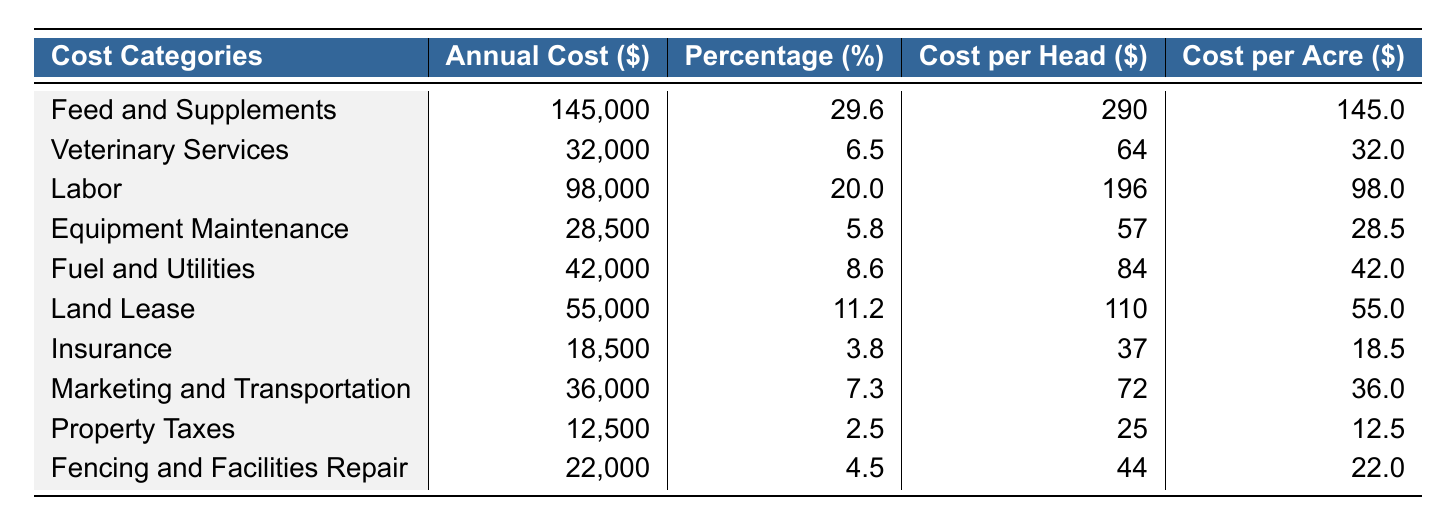What is the annual cost of Feed and Supplements? The table lists the annual costs for each category, and for Feed and Supplements, the value is directly provided as 145,000 dollars.
Answer: 145000 What percentage of total costs does Labor account for? The table shows that Labor accounts for 20.0% of the total costs, as noted in the Percentage column next to Labor.
Answer: 20.0% Which cost category has the highest annual cost? By comparing all annual cost values in the table, Feed and Supplements has the highest value at 145,000 dollars.
Answer: Feed and Supplements What is the total annual cost for Veterinary Services and Insurance combined? The annual cost for Veterinary Services is 32,000 dollars, and for Insurance, it's 18,500 dollars. Adding these gives 32,000 + 18,500 = 50,500 dollars as the total.
Answer: 50500 Is the annual cost for Fencing and Facilities Repair more or less than that for Property Taxes? The annual cost for Fencing and Facilities Repair is 22,000 dollars, and for Property Taxes, it is 12,500 dollars. Since 22,000 is greater than 12,500, the answer is that it is more.
Answer: More What is the average cost per head of all categories? First, add all the costs per head: 290 + 64 + 196 + 57 + 84 + 110 + 37 + 72 + 25 + 44 = 979. Then divide this sum by the 10 categories, which is 979 / 10 = 97.9 dollars.
Answer: 97.9 Which category has the lowest cost per acre? By examining the Cost per Acre column, Property Taxes has the lowest value at 12.5 dollars per acre.
Answer: Property Taxes What is the difference in annual cost between Equipment Maintenance and Fuel and Utilities? The annual cost for Equipment Maintenance is 28,500 dollars, and for Fuel and Utilities, it is 42,000 dollars. The difference is 42,000 - 28,500 = 13,500 dollars.
Answer: 13500 If you were to increase the budget for Labor by 10%, what would the new budget be? The current annual cost for Labor is 98,000 dollars. Increasing by 10% gives 98,000 * 0.10 = 9,800. Therefore, the new budget would be 98,000 + 9,800 = 107,800 dollars.
Answer: 107800 What is the total cost for categories that account for more than 10% of the total costs? The categories that exceed 10% are Feed and Supplements (29.6%), Labor (20.0%), and Land Lease (11.2%). Their respective costs are 145,000 + 98,000 + 55,000 = 298,000 dollars.
Answer: 298000 